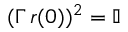Convert formula to latex. <formula><loc_0><loc_0><loc_500><loc_500>( \Gamma \, r ( 0 ) ) ^ { 2 } = \mathbb { I }</formula> 